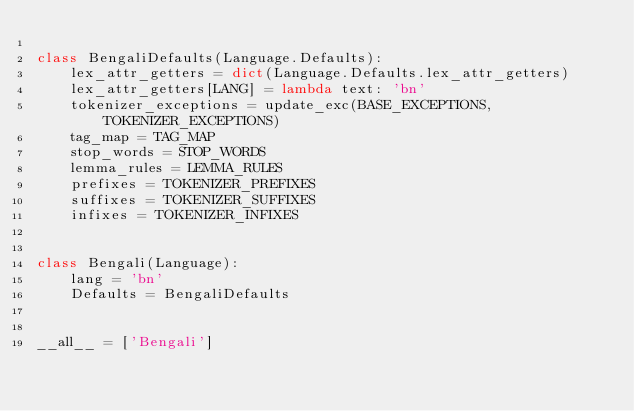Convert code to text. <code><loc_0><loc_0><loc_500><loc_500><_Python_>
class BengaliDefaults(Language.Defaults):
    lex_attr_getters = dict(Language.Defaults.lex_attr_getters)
    lex_attr_getters[LANG] = lambda text: 'bn'
    tokenizer_exceptions = update_exc(BASE_EXCEPTIONS, TOKENIZER_EXCEPTIONS)
    tag_map = TAG_MAP
    stop_words = STOP_WORDS
    lemma_rules = LEMMA_RULES
    prefixes = TOKENIZER_PREFIXES
    suffixes = TOKENIZER_SUFFIXES
    infixes = TOKENIZER_INFIXES


class Bengali(Language):
    lang = 'bn'
    Defaults = BengaliDefaults


__all__ = ['Bengali']
</code> 